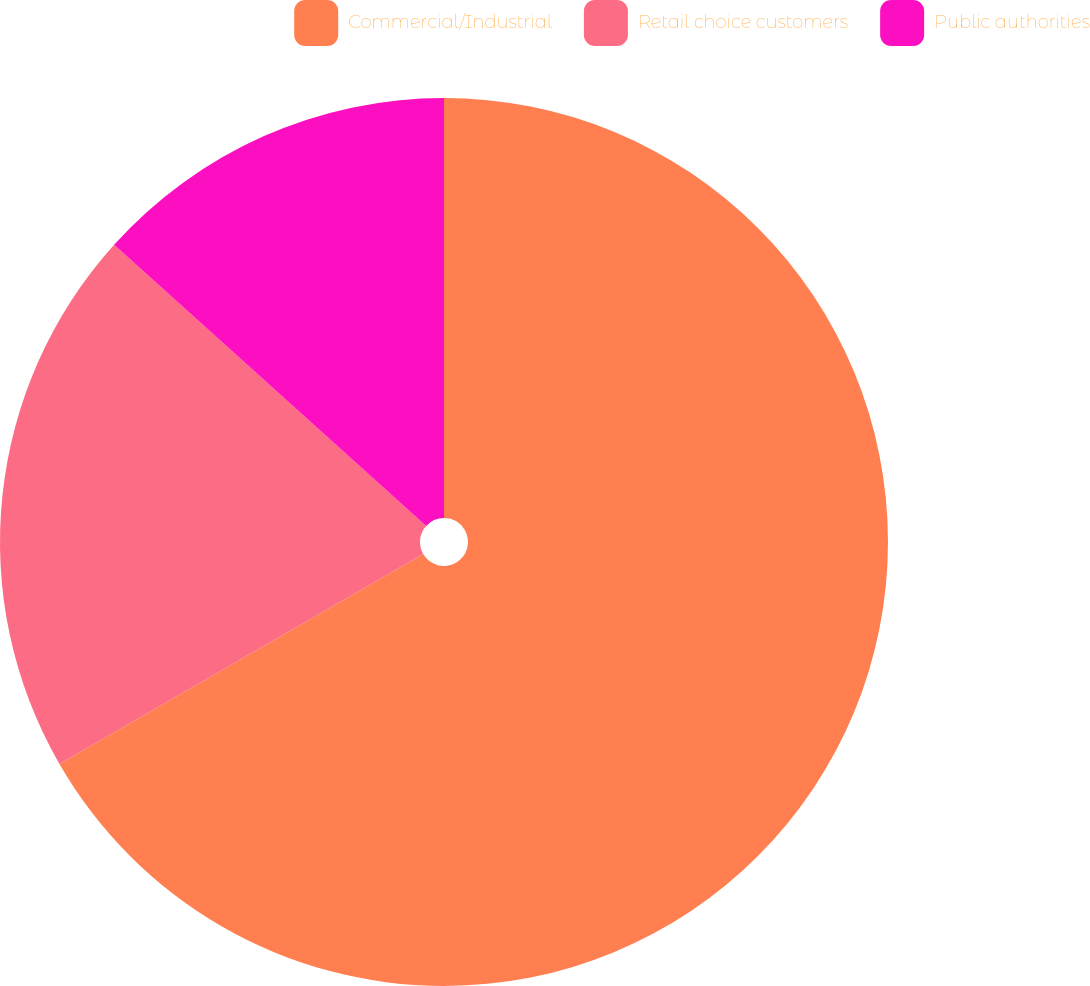Convert chart to OTSL. <chart><loc_0><loc_0><loc_500><loc_500><pie_chart><fcel>Commercial/Industrial<fcel>Retail choice customers<fcel>Public authorities<nl><fcel>66.67%<fcel>20.0%<fcel>13.33%<nl></chart> 